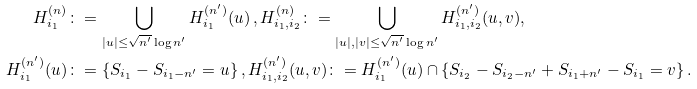<formula> <loc_0><loc_0><loc_500><loc_500>H ^ { ( n ) } _ { i _ { 1 } } & \colon = \bigcup _ { | u | \leq \sqrt { n ^ { \prime } } \log n ^ { \prime } } H ^ { ( n ^ { \prime } ) } _ { i _ { 1 } } ( u ) \, , H _ { i _ { 1 } , i _ { 2 } } ^ { ( n ) } \colon = \bigcup _ { | u | , | v | \leq \sqrt { n ^ { \prime } } \log n ^ { \prime } } H ^ { ( n ^ { \prime } ) } _ { i _ { 1 } , i _ { 2 } } ( u , v ) , \\ H ^ { ( n ^ { \prime } ) } _ { i _ { 1 } } ( u ) & \colon = \{ S _ { i _ { 1 } } - S _ { i _ { 1 } - n ^ { \prime } } = u \} \, , H ^ { ( n ^ { \prime } ) } _ { i _ { 1 } , i _ { 2 } } ( u , v ) \colon = H ^ { ( n ^ { \prime } ) } _ { i _ { 1 } } ( u ) \cap \{ S _ { i _ { 2 } } - S _ { i _ { 2 } - n ^ { \prime } } + S _ { { i _ { 1 } } + n ^ { \prime } } - S _ { i _ { 1 } } = v \} \, .</formula> 